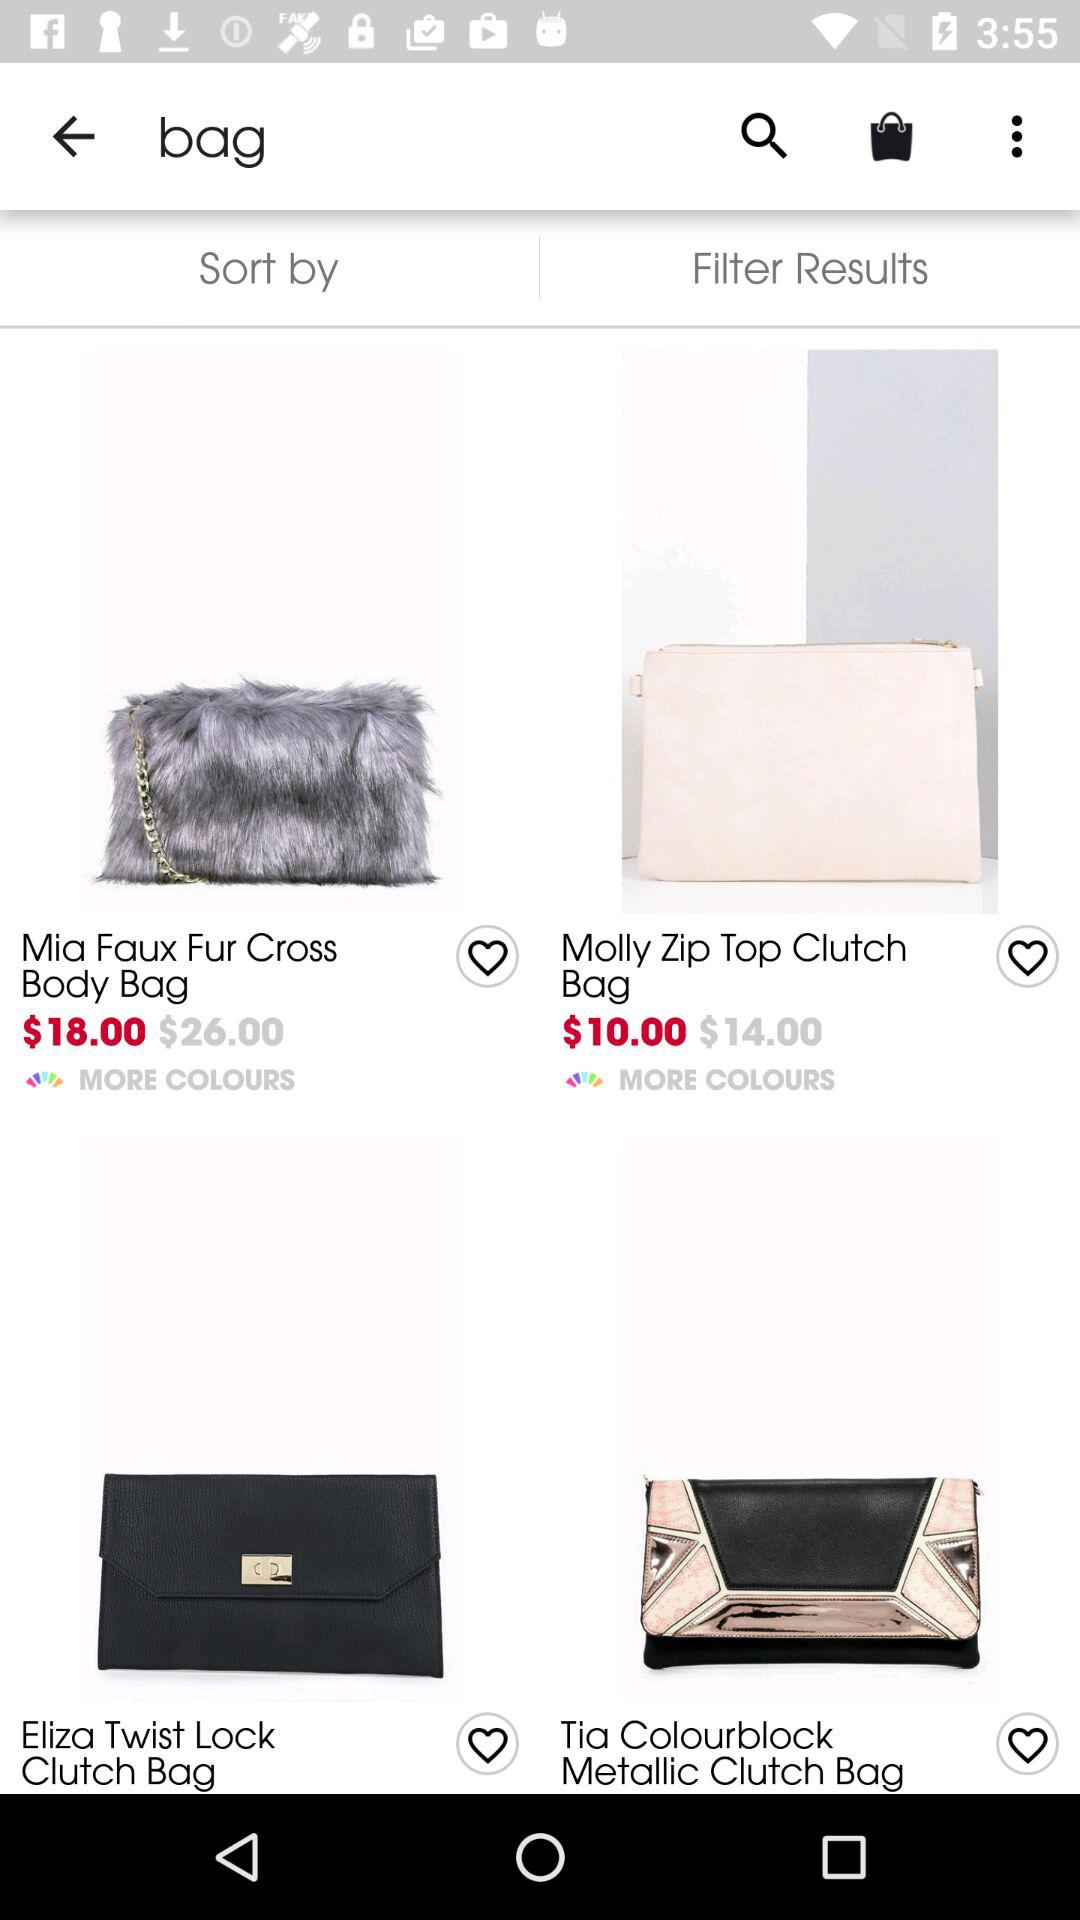What is the price of the "Molly Zip Top Clutch" bag after a discount? The price is $10. 